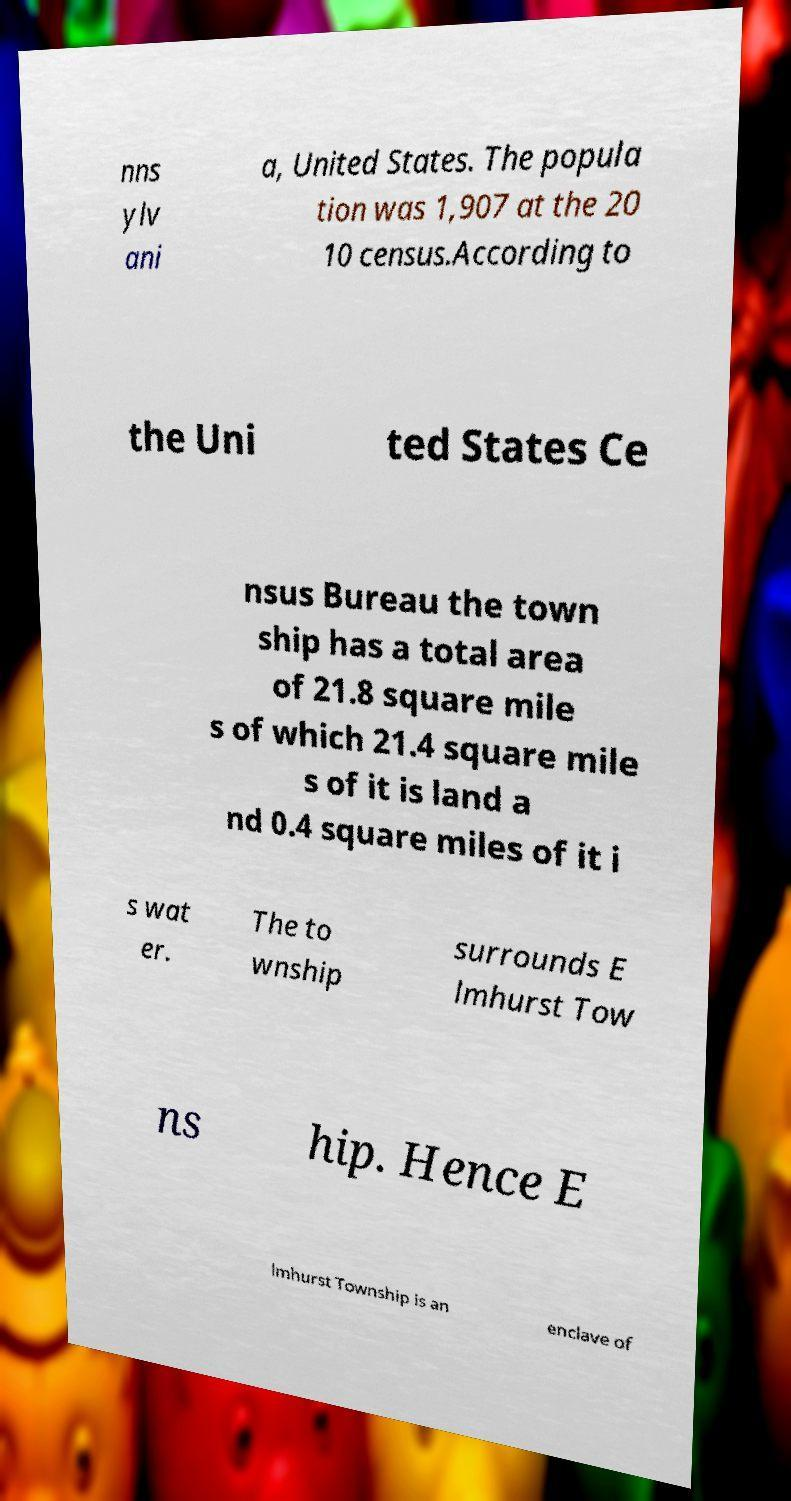Can you accurately transcribe the text from the provided image for me? nns ylv ani a, United States. The popula tion was 1,907 at the 20 10 census.According to the Uni ted States Ce nsus Bureau the town ship has a total area of 21.8 square mile s of which 21.4 square mile s of it is land a nd 0.4 square miles of it i s wat er. The to wnship surrounds E lmhurst Tow ns hip. Hence E lmhurst Township is an enclave of 